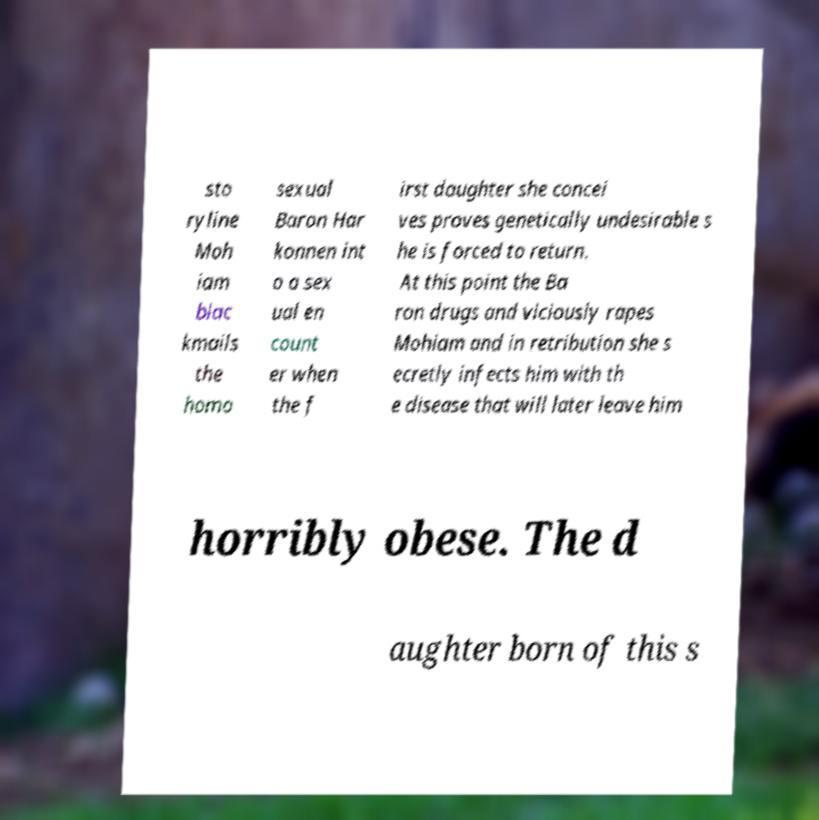I need the written content from this picture converted into text. Can you do that? sto ryline Moh iam blac kmails the homo sexual Baron Har konnen int o a sex ual en count er when the f irst daughter she concei ves proves genetically undesirable s he is forced to return. At this point the Ba ron drugs and viciously rapes Mohiam and in retribution she s ecretly infects him with th e disease that will later leave him horribly obese. The d aughter born of this s 